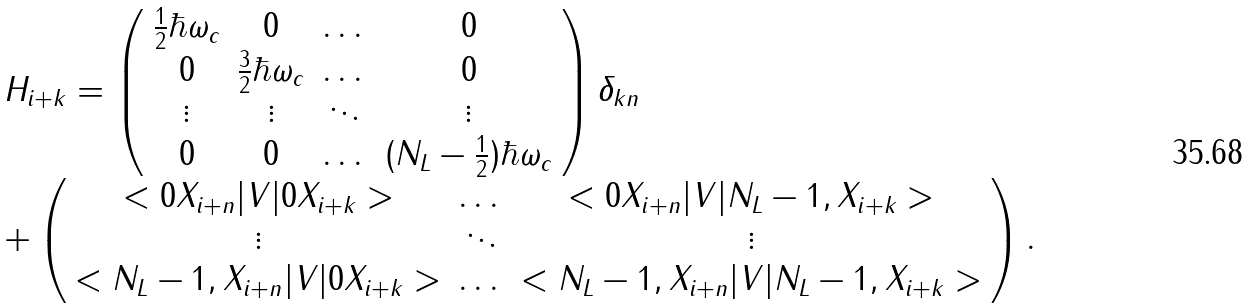Convert formula to latex. <formula><loc_0><loc_0><loc_500><loc_500>\begin{array} { l } H _ { i + k } = \left ( \begin{array} { c c c c } \frac { 1 } { 2 } \hbar { \omega } _ { c } & 0 & \dots & 0 \\ 0 & \frac { 3 } { 2 } \hbar { \omega } _ { c } & \dots & 0 \\ \vdots & \vdots & \ddots & \vdots \\ 0 & 0 & \dots & ( N _ { L } - \frac { 1 } { 2 } ) \hbar { \omega } _ { c } \end{array} \right ) \delta _ { k n } \\ + \left ( \begin{array} { c c c } < 0 X _ { i + n } | V | 0 X _ { i + k } > & \dots & < 0 X _ { i + n } | V | N _ { L } - 1 , X _ { i + k } > \\ \vdots & \ddots & \vdots \\ < N _ { L } - 1 , X _ { i + n } | V | 0 X _ { i + k } > & \dots & < N _ { L } - 1 , X _ { i + n } | V | N _ { L } - 1 , X _ { i + k } > \end{array} \right ) . \end{array}</formula> 